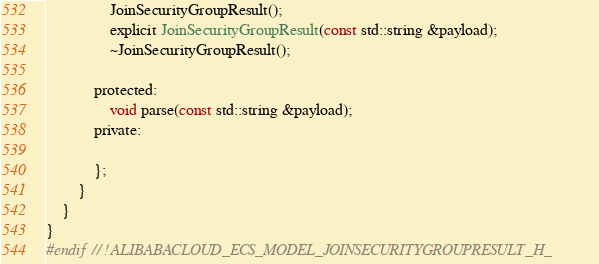Convert code to text. <code><loc_0><loc_0><loc_500><loc_500><_C_>				JoinSecurityGroupResult();
				explicit JoinSecurityGroupResult(const std::string &payload);
				~JoinSecurityGroupResult();

			protected:
				void parse(const std::string &payload);
			private:

			};
		}
	}
}
#endif // !ALIBABACLOUD_ECS_MODEL_JOINSECURITYGROUPRESULT_H_</code> 